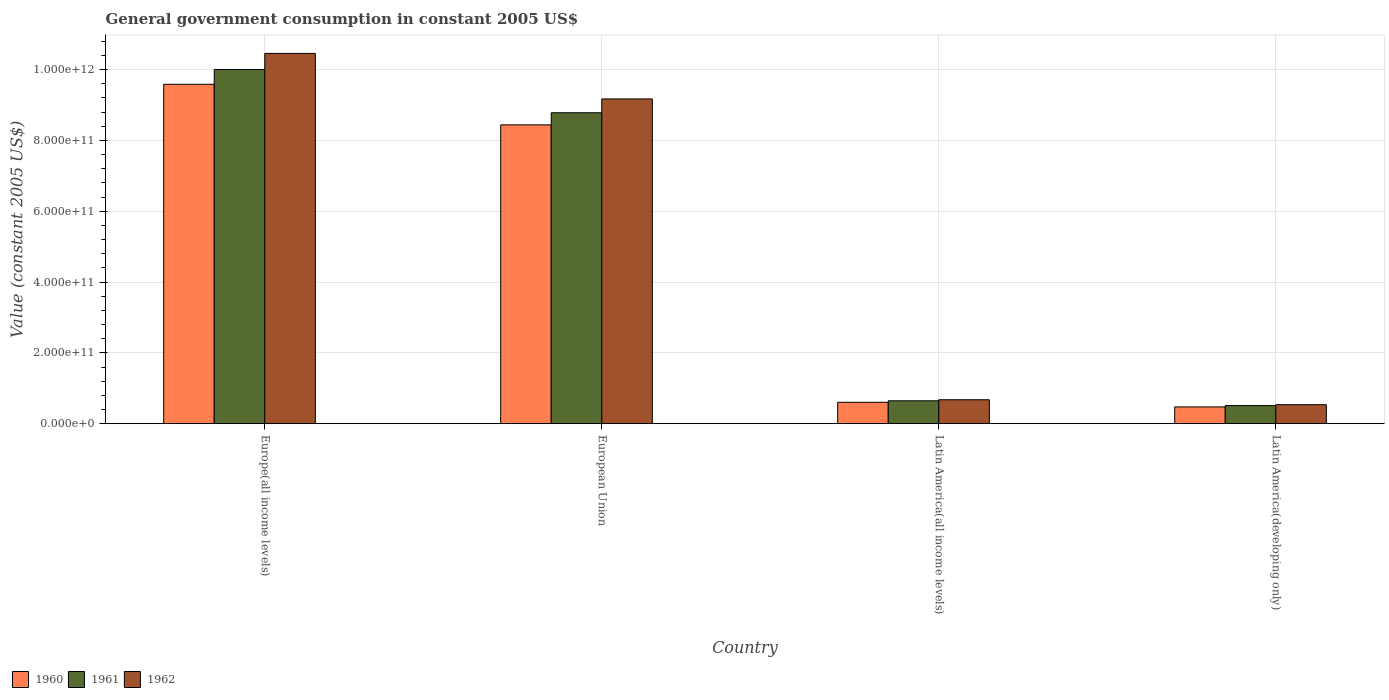Are the number of bars per tick equal to the number of legend labels?
Offer a very short reply. Yes. Are the number of bars on each tick of the X-axis equal?
Your answer should be compact. Yes. How many bars are there on the 1st tick from the left?
Offer a very short reply. 3. How many bars are there on the 4th tick from the right?
Give a very brief answer. 3. What is the label of the 4th group of bars from the left?
Provide a short and direct response. Latin America(developing only). In how many cases, is the number of bars for a given country not equal to the number of legend labels?
Offer a very short reply. 0. What is the government conusmption in 1961 in Europe(all income levels)?
Your response must be concise. 1.00e+12. Across all countries, what is the maximum government conusmption in 1960?
Your answer should be compact. 9.58e+11. Across all countries, what is the minimum government conusmption in 1962?
Provide a succinct answer. 5.38e+1. In which country was the government conusmption in 1961 maximum?
Provide a short and direct response. Europe(all income levels). In which country was the government conusmption in 1962 minimum?
Offer a very short reply. Latin America(developing only). What is the total government conusmption in 1962 in the graph?
Provide a short and direct response. 2.08e+12. What is the difference between the government conusmption in 1960 in European Union and that in Latin America(all income levels)?
Your answer should be compact. 7.83e+11. What is the difference between the government conusmption in 1961 in Europe(all income levels) and the government conusmption in 1962 in Latin America(all income levels)?
Ensure brevity in your answer.  9.32e+11. What is the average government conusmption in 1960 per country?
Give a very brief answer. 4.78e+11. What is the difference between the government conusmption of/in 1962 and government conusmption of/in 1961 in Europe(all income levels)?
Make the answer very short. 4.54e+1. What is the ratio of the government conusmption in 1962 in Europe(all income levels) to that in Latin America(developing only)?
Your response must be concise. 19.43. Is the government conusmption in 1962 in Europe(all income levels) less than that in Latin America(all income levels)?
Your response must be concise. No. Is the difference between the government conusmption in 1962 in Europe(all income levels) and European Union greater than the difference between the government conusmption in 1961 in Europe(all income levels) and European Union?
Keep it short and to the point. Yes. What is the difference between the highest and the second highest government conusmption in 1960?
Give a very brief answer. 8.98e+11. What is the difference between the highest and the lowest government conusmption in 1961?
Your answer should be compact. 9.49e+11. Is the sum of the government conusmption in 1962 in Europe(all income levels) and Latin America(all income levels) greater than the maximum government conusmption in 1960 across all countries?
Make the answer very short. Yes. Is it the case that in every country, the sum of the government conusmption in 1962 and government conusmption in 1960 is greater than the government conusmption in 1961?
Your response must be concise. Yes. How many bars are there?
Make the answer very short. 12. Are all the bars in the graph horizontal?
Your answer should be compact. No. What is the difference between two consecutive major ticks on the Y-axis?
Offer a very short reply. 2.00e+11. Are the values on the major ticks of Y-axis written in scientific E-notation?
Ensure brevity in your answer.  Yes. How many legend labels are there?
Keep it short and to the point. 3. How are the legend labels stacked?
Give a very brief answer. Horizontal. What is the title of the graph?
Provide a succinct answer. General government consumption in constant 2005 US$. What is the label or title of the X-axis?
Offer a terse response. Country. What is the label or title of the Y-axis?
Your response must be concise. Value (constant 2005 US$). What is the Value (constant 2005 US$) in 1960 in Europe(all income levels)?
Your response must be concise. 9.58e+11. What is the Value (constant 2005 US$) in 1961 in Europe(all income levels)?
Give a very brief answer. 1.00e+12. What is the Value (constant 2005 US$) in 1962 in Europe(all income levels)?
Provide a short and direct response. 1.05e+12. What is the Value (constant 2005 US$) in 1960 in European Union?
Keep it short and to the point. 8.44e+11. What is the Value (constant 2005 US$) of 1961 in European Union?
Your answer should be very brief. 8.78e+11. What is the Value (constant 2005 US$) in 1962 in European Union?
Offer a very short reply. 9.17e+11. What is the Value (constant 2005 US$) of 1960 in Latin America(all income levels)?
Your response must be concise. 6.06e+1. What is the Value (constant 2005 US$) of 1961 in Latin America(all income levels)?
Your answer should be very brief. 6.47e+1. What is the Value (constant 2005 US$) in 1962 in Latin America(all income levels)?
Offer a terse response. 6.77e+1. What is the Value (constant 2005 US$) of 1960 in Latin America(developing only)?
Your response must be concise. 4.75e+1. What is the Value (constant 2005 US$) in 1961 in Latin America(developing only)?
Offer a very short reply. 5.13e+1. What is the Value (constant 2005 US$) of 1962 in Latin America(developing only)?
Your answer should be compact. 5.38e+1. Across all countries, what is the maximum Value (constant 2005 US$) of 1960?
Make the answer very short. 9.58e+11. Across all countries, what is the maximum Value (constant 2005 US$) of 1961?
Ensure brevity in your answer.  1.00e+12. Across all countries, what is the maximum Value (constant 2005 US$) in 1962?
Make the answer very short. 1.05e+12. Across all countries, what is the minimum Value (constant 2005 US$) of 1960?
Make the answer very short. 4.75e+1. Across all countries, what is the minimum Value (constant 2005 US$) of 1961?
Offer a very short reply. 5.13e+1. Across all countries, what is the minimum Value (constant 2005 US$) in 1962?
Your answer should be very brief. 5.38e+1. What is the total Value (constant 2005 US$) in 1960 in the graph?
Your answer should be compact. 1.91e+12. What is the total Value (constant 2005 US$) in 1961 in the graph?
Give a very brief answer. 1.99e+12. What is the total Value (constant 2005 US$) in 1962 in the graph?
Keep it short and to the point. 2.08e+12. What is the difference between the Value (constant 2005 US$) in 1960 in Europe(all income levels) and that in European Union?
Provide a succinct answer. 1.15e+11. What is the difference between the Value (constant 2005 US$) in 1961 in Europe(all income levels) and that in European Union?
Provide a succinct answer. 1.22e+11. What is the difference between the Value (constant 2005 US$) of 1962 in Europe(all income levels) and that in European Union?
Keep it short and to the point. 1.29e+11. What is the difference between the Value (constant 2005 US$) of 1960 in Europe(all income levels) and that in Latin America(all income levels)?
Your answer should be very brief. 8.98e+11. What is the difference between the Value (constant 2005 US$) of 1961 in Europe(all income levels) and that in Latin America(all income levels)?
Ensure brevity in your answer.  9.35e+11. What is the difference between the Value (constant 2005 US$) in 1962 in Europe(all income levels) and that in Latin America(all income levels)?
Your answer should be very brief. 9.78e+11. What is the difference between the Value (constant 2005 US$) in 1960 in Europe(all income levels) and that in Latin America(developing only)?
Provide a short and direct response. 9.11e+11. What is the difference between the Value (constant 2005 US$) in 1961 in Europe(all income levels) and that in Latin America(developing only)?
Give a very brief answer. 9.49e+11. What is the difference between the Value (constant 2005 US$) of 1962 in Europe(all income levels) and that in Latin America(developing only)?
Keep it short and to the point. 9.92e+11. What is the difference between the Value (constant 2005 US$) of 1960 in European Union and that in Latin America(all income levels)?
Your answer should be very brief. 7.83e+11. What is the difference between the Value (constant 2005 US$) of 1961 in European Union and that in Latin America(all income levels)?
Ensure brevity in your answer.  8.13e+11. What is the difference between the Value (constant 2005 US$) of 1962 in European Union and that in Latin America(all income levels)?
Provide a succinct answer. 8.49e+11. What is the difference between the Value (constant 2005 US$) in 1960 in European Union and that in Latin America(developing only)?
Provide a short and direct response. 7.96e+11. What is the difference between the Value (constant 2005 US$) of 1961 in European Union and that in Latin America(developing only)?
Give a very brief answer. 8.27e+11. What is the difference between the Value (constant 2005 US$) of 1962 in European Union and that in Latin America(developing only)?
Offer a terse response. 8.63e+11. What is the difference between the Value (constant 2005 US$) of 1960 in Latin America(all income levels) and that in Latin America(developing only)?
Offer a terse response. 1.31e+1. What is the difference between the Value (constant 2005 US$) of 1961 in Latin America(all income levels) and that in Latin America(developing only)?
Make the answer very short. 1.35e+1. What is the difference between the Value (constant 2005 US$) of 1962 in Latin America(all income levels) and that in Latin America(developing only)?
Offer a terse response. 1.39e+1. What is the difference between the Value (constant 2005 US$) in 1960 in Europe(all income levels) and the Value (constant 2005 US$) in 1961 in European Union?
Give a very brief answer. 8.03e+1. What is the difference between the Value (constant 2005 US$) in 1960 in Europe(all income levels) and the Value (constant 2005 US$) in 1962 in European Union?
Ensure brevity in your answer.  4.13e+1. What is the difference between the Value (constant 2005 US$) of 1961 in Europe(all income levels) and the Value (constant 2005 US$) of 1962 in European Union?
Your answer should be compact. 8.31e+1. What is the difference between the Value (constant 2005 US$) of 1960 in Europe(all income levels) and the Value (constant 2005 US$) of 1961 in Latin America(all income levels)?
Your answer should be compact. 8.94e+11. What is the difference between the Value (constant 2005 US$) in 1960 in Europe(all income levels) and the Value (constant 2005 US$) in 1962 in Latin America(all income levels)?
Your response must be concise. 8.91e+11. What is the difference between the Value (constant 2005 US$) in 1961 in Europe(all income levels) and the Value (constant 2005 US$) in 1962 in Latin America(all income levels)?
Give a very brief answer. 9.32e+11. What is the difference between the Value (constant 2005 US$) in 1960 in Europe(all income levels) and the Value (constant 2005 US$) in 1961 in Latin America(developing only)?
Offer a very short reply. 9.07e+11. What is the difference between the Value (constant 2005 US$) of 1960 in Europe(all income levels) and the Value (constant 2005 US$) of 1962 in Latin America(developing only)?
Offer a very short reply. 9.05e+11. What is the difference between the Value (constant 2005 US$) of 1961 in Europe(all income levels) and the Value (constant 2005 US$) of 1962 in Latin America(developing only)?
Your answer should be compact. 9.46e+11. What is the difference between the Value (constant 2005 US$) in 1960 in European Union and the Value (constant 2005 US$) in 1961 in Latin America(all income levels)?
Ensure brevity in your answer.  7.79e+11. What is the difference between the Value (constant 2005 US$) of 1960 in European Union and the Value (constant 2005 US$) of 1962 in Latin America(all income levels)?
Your answer should be compact. 7.76e+11. What is the difference between the Value (constant 2005 US$) of 1961 in European Union and the Value (constant 2005 US$) of 1962 in Latin America(all income levels)?
Your answer should be very brief. 8.10e+11. What is the difference between the Value (constant 2005 US$) in 1960 in European Union and the Value (constant 2005 US$) in 1961 in Latin America(developing only)?
Your response must be concise. 7.93e+11. What is the difference between the Value (constant 2005 US$) of 1960 in European Union and the Value (constant 2005 US$) of 1962 in Latin America(developing only)?
Your answer should be very brief. 7.90e+11. What is the difference between the Value (constant 2005 US$) of 1961 in European Union and the Value (constant 2005 US$) of 1962 in Latin America(developing only)?
Make the answer very short. 8.24e+11. What is the difference between the Value (constant 2005 US$) in 1960 in Latin America(all income levels) and the Value (constant 2005 US$) in 1961 in Latin America(developing only)?
Your answer should be very brief. 9.29e+09. What is the difference between the Value (constant 2005 US$) of 1960 in Latin America(all income levels) and the Value (constant 2005 US$) of 1962 in Latin America(developing only)?
Your response must be concise. 6.76e+09. What is the difference between the Value (constant 2005 US$) of 1961 in Latin America(all income levels) and the Value (constant 2005 US$) of 1962 in Latin America(developing only)?
Your answer should be very brief. 1.09e+1. What is the average Value (constant 2005 US$) of 1960 per country?
Offer a terse response. 4.78e+11. What is the average Value (constant 2005 US$) in 1961 per country?
Provide a succinct answer. 4.99e+11. What is the average Value (constant 2005 US$) in 1962 per country?
Ensure brevity in your answer.  5.21e+11. What is the difference between the Value (constant 2005 US$) of 1960 and Value (constant 2005 US$) of 1961 in Europe(all income levels)?
Provide a short and direct response. -4.18e+1. What is the difference between the Value (constant 2005 US$) of 1960 and Value (constant 2005 US$) of 1962 in Europe(all income levels)?
Give a very brief answer. -8.73e+1. What is the difference between the Value (constant 2005 US$) of 1961 and Value (constant 2005 US$) of 1962 in Europe(all income levels)?
Give a very brief answer. -4.54e+1. What is the difference between the Value (constant 2005 US$) in 1960 and Value (constant 2005 US$) in 1961 in European Union?
Your response must be concise. -3.42e+1. What is the difference between the Value (constant 2005 US$) of 1960 and Value (constant 2005 US$) of 1962 in European Union?
Give a very brief answer. -7.32e+1. What is the difference between the Value (constant 2005 US$) in 1961 and Value (constant 2005 US$) in 1962 in European Union?
Provide a succinct answer. -3.90e+1. What is the difference between the Value (constant 2005 US$) of 1960 and Value (constant 2005 US$) of 1961 in Latin America(all income levels)?
Provide a short and direct response. -4.16e+09. What is the difference between the Value (constant 2005 US$) of 1960 and Value (constant 2005 US$) of 1962 in Latin America(all income levels)?
Provide a short and direct response. -7.17e+09. What is the difference between the Value (constant 2005 US$) of 1961 and Value (constant 2005 US$) of 1962 in Latin America(all income levels)?
Ensure brevity in your answer.  -3.01e+09. What is the difference between the Value (constant 2005 US$) of 1960 and Value (constant 2005 US$) of 1961 in Latin America(developing only)?
Your answer should be compact. -3.79e+09. What is the difference between the Value (constant 2005 US$) of 1960 and Value (constant 2005 US$) of 1962 in Latin America(developing only)?
Your answer should be very brief. -6.32e+09. What is the difference between the Value (constant 2005 US$) of 1961 and Value (constant 2005 US$) of 1962 in Latin America(developing only)?
Give a very brief answer. -2.53e+09. What is the ratio of the Value (constant 2005 US$) in 1960 in Europe(all income levels) to that in European Union?
Offer a very short reply. 1.14. What is the ratio of the Value (constant 2005 US$) in 1961 in Europe(all income levels) to that in European Union?
Make the answer very short. 1.14. What is the ratio of the Value (constant 2005 US$) of 1962 in Europe(all income levels) to that in European Union?
Ensure brevity in your answer.  1.14. What is the ratio of the Value (constant 2005 US$) in 1960 in Europe(all income levels) to that in Latin America(all income levels)?
Make the answer very short. 15.82. What is the ratio of the Value (constant 2005 US$) in 1961 in Europe(all income levels) to that in Latin America(all income levels)?
Keep it short and to the point. 15.45. What is the ratio of the Value (constant 2005 US$) of 1962 in Europe(all income levels) to that in Latin America(all income levels)?
Ensure brevity in your answer.  15.43. What is the ratio of the Value (constant 2005 US$) of 1960 in Europe(all income levels) to that in Latin America(developing only)?
Provide a succinct answer. 20.18. What is the ratio of the Value (constant 2005 US$) of 1961 in Europe(all income levels) to that in Latin America(developing only)?
Your answer should be very brief. 19.5. What is the ratio of the Value (constant 2005 US$) in 1962 in Europe(all income levels) to that in Latin America(developing only)?
Provide a succinct answer. 19.43. What is the ratio of the Value (constant 2005 US$) in 1960 in European Union to that in Latin America(all income levels)?
Ensure brevity in your answer.  13.93. What is the ratio of the Value (constant 2005 US$) of 1961 in European Union to that in Latin America(all income levels)?
Your answer should be very brief. 13.56. What is the ratio of the Value (constant 2005 US$) of 1962 in European Union to that in Latin America(all income levels)?
Your answer should be compact. 13.54. What is the ratio of the Value (constant 2005 US$) of 1960 in European Union to that in Latin America(developing only)?
Give a very brief answer. 17.77. What is the ratio of the Value (constant 2005 US$) of 1961 in European Union to that in Latin America(developing only)?
Ensure brevity in your answer.  17.12. What is the ratio of the Value (constant 2005 US$) in 1962 in European Union to that in Latin America(developing only)?
Your answer should be very brief. 17.04. What is the ratio of the Value (constant 2005 US$) of 1960 in Latin America(all income levels) to that in Latin America(developing only)?
Provide a short and direct response. 1.28. What is the ratio of the Value (constant 2005 US$) in 1961 in Latin America(all income levels) to that in Latin America(developing only)?
Your response must be concise. 1.26. What is the ratio of the Value (constant 2005 US$) in 1962 in Latin America(all income levels) to that in Latin America(developing only)?
Offer a terse response. 1.26. What is the difference between the highest and the second highest Value (constant 2005 US$) in 1960?
Offer a terse response. 1.15e+11. What is the difference between the highest and the second highest Value (constant 2005 US$) of 1961?
Your answer should be compact. 1.22e+11. What is the difference between the highest and the second highest Value (constant 2005 US$) in 1962?
Make the answer very short. 1.29e+11. What is the difference between the highest and the lowest Value (constant 2005 US$) of 1960?
Make the answer very short. 9.11e+11. What is the difference between the highest and the lowest Value (constant 2005 US$) of 1961?
Ensure brevity in your answer.  9.49e+11. What is the difference between the highest and the lowest Value (constant 2005 US$) in 1962?
Make the answer very short. 9.92e+11. 